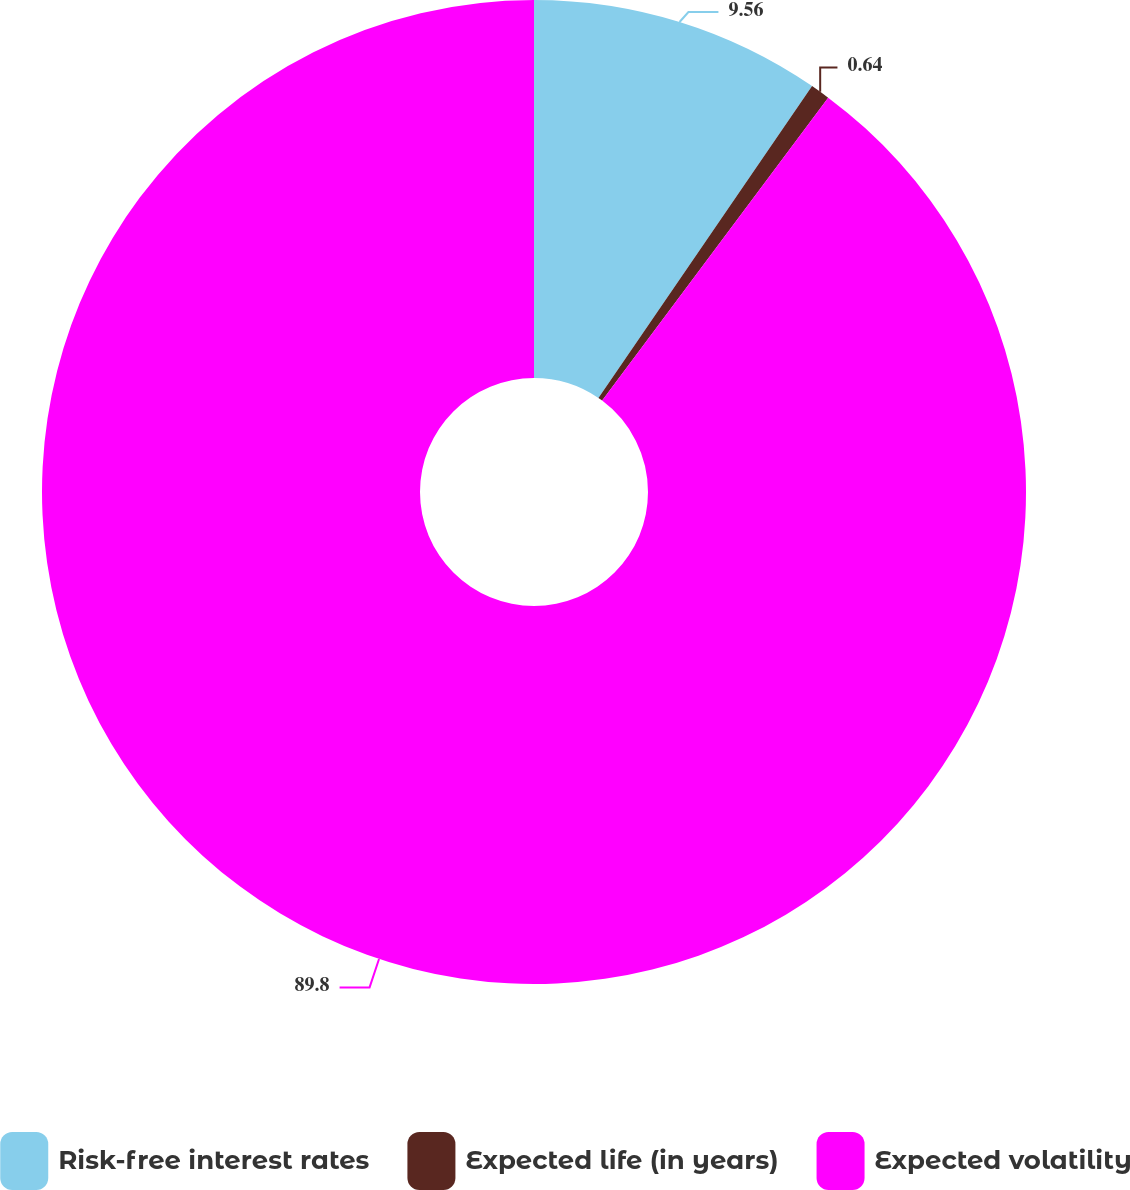Convert chart to OTSL. <chart><loc_0><loc_0><loc_500><loc_500><pie_chart><fcel>Risk-free interest rates<fcel>Expected life (in years)<fcel>Expected volatility<nl><fcel>9.56%<fcel>0.64%<fcel>89.8%<nl></chart> 